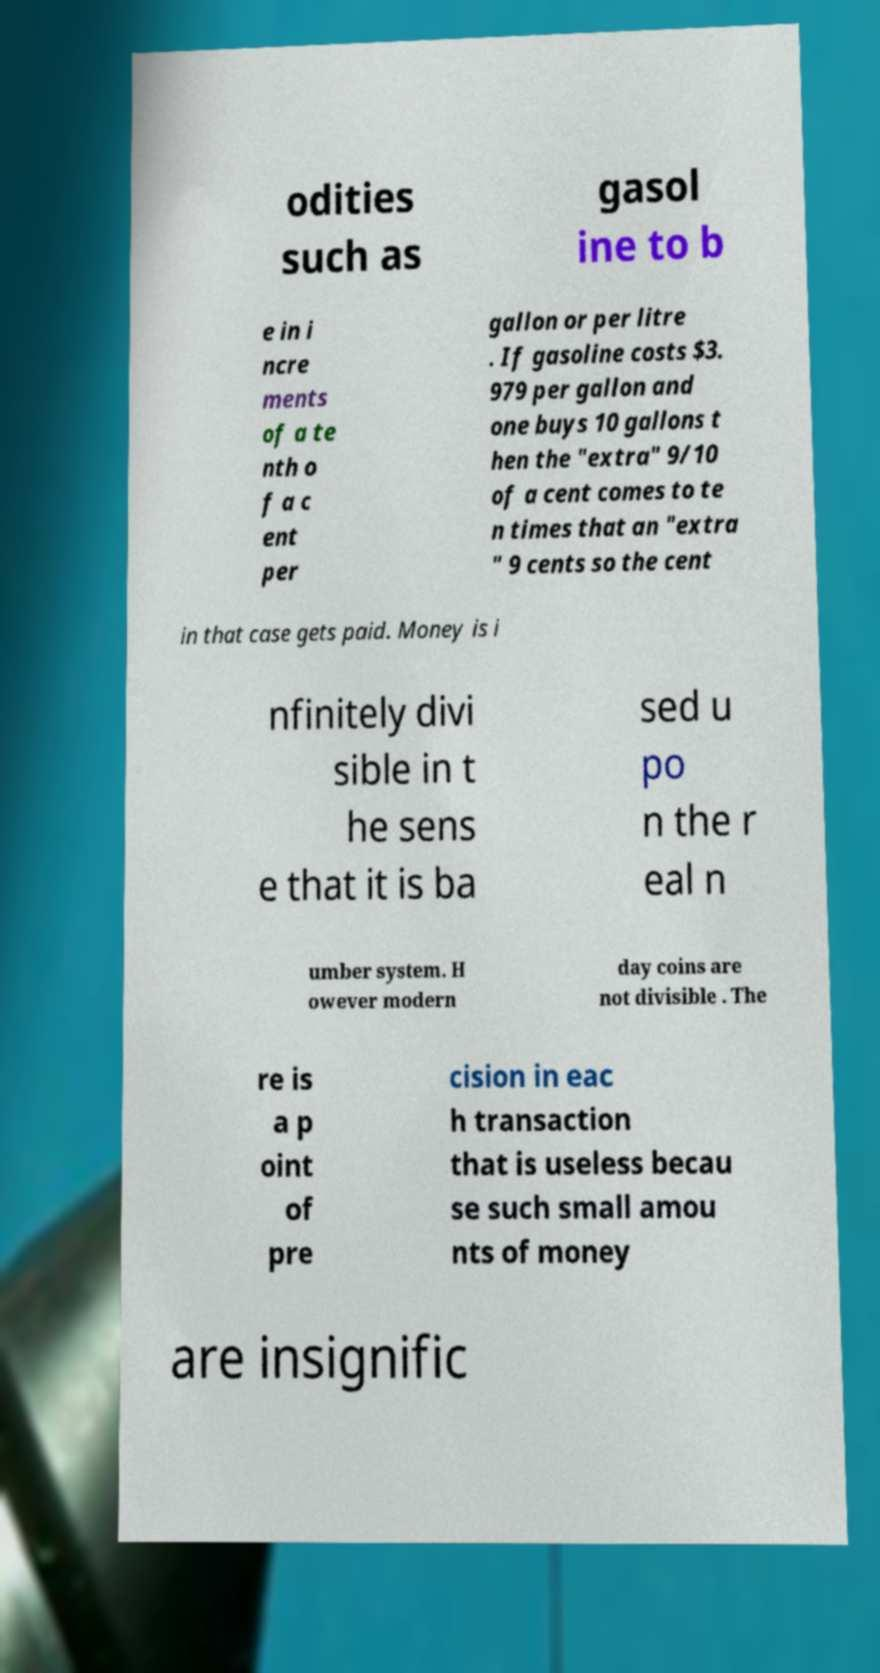Could you extract and type out the text from this image? odities such as gasol ine to b e in i ncre ments of a te nth o f a c ent per gallon or per litre . If gasoline costs $3. 979 per gallon and one buys 10 gallons t hen the "extra" 9/10 of a cent comes to te n times that an "extra " 9 cents so the cent in that case gets paid. Money is i nfinitely divi sible in t he sens e that it is ba sed u po n the r eal n umber system. H owever modern day coins are not divisible . The re is a p oint of pre cision in eac h transaction that is useless becau se such small amou nts of money are insignific 